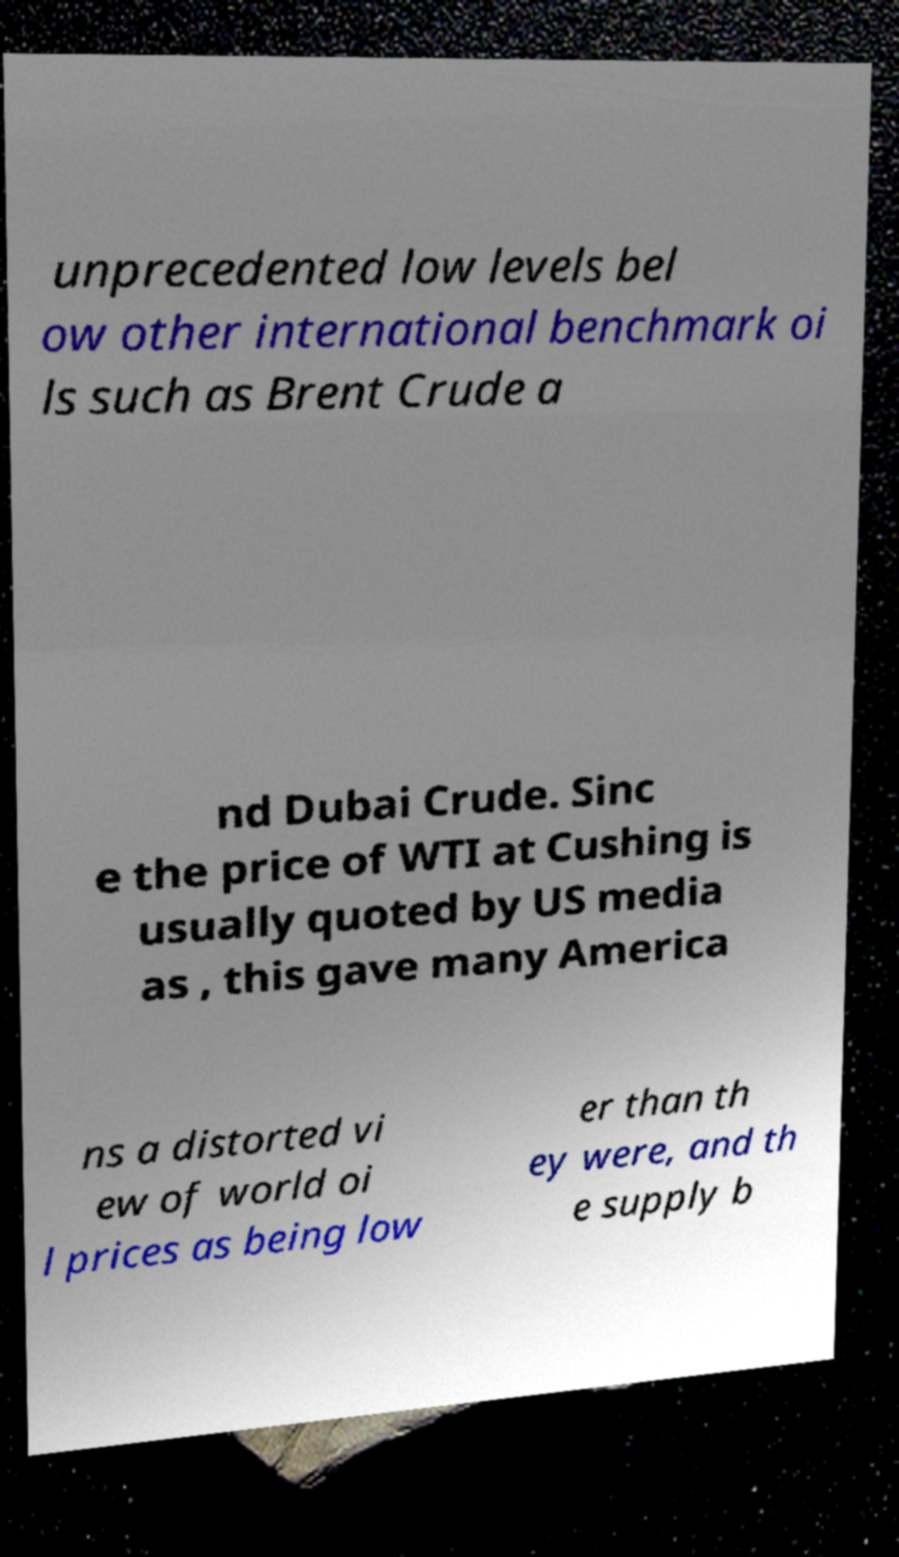Can you accurately transcribe the text from the provided image for me? unprecedented low levels bel ow other international benchmark oi ls such as Brent Crude a nd Dubai Crude. Sinc e the price of WTI at Cushing is usually quoted by US media as , this gave many America ns a distorted vi ew of world oi l prices as being low er than th ey were, and th e supply b 